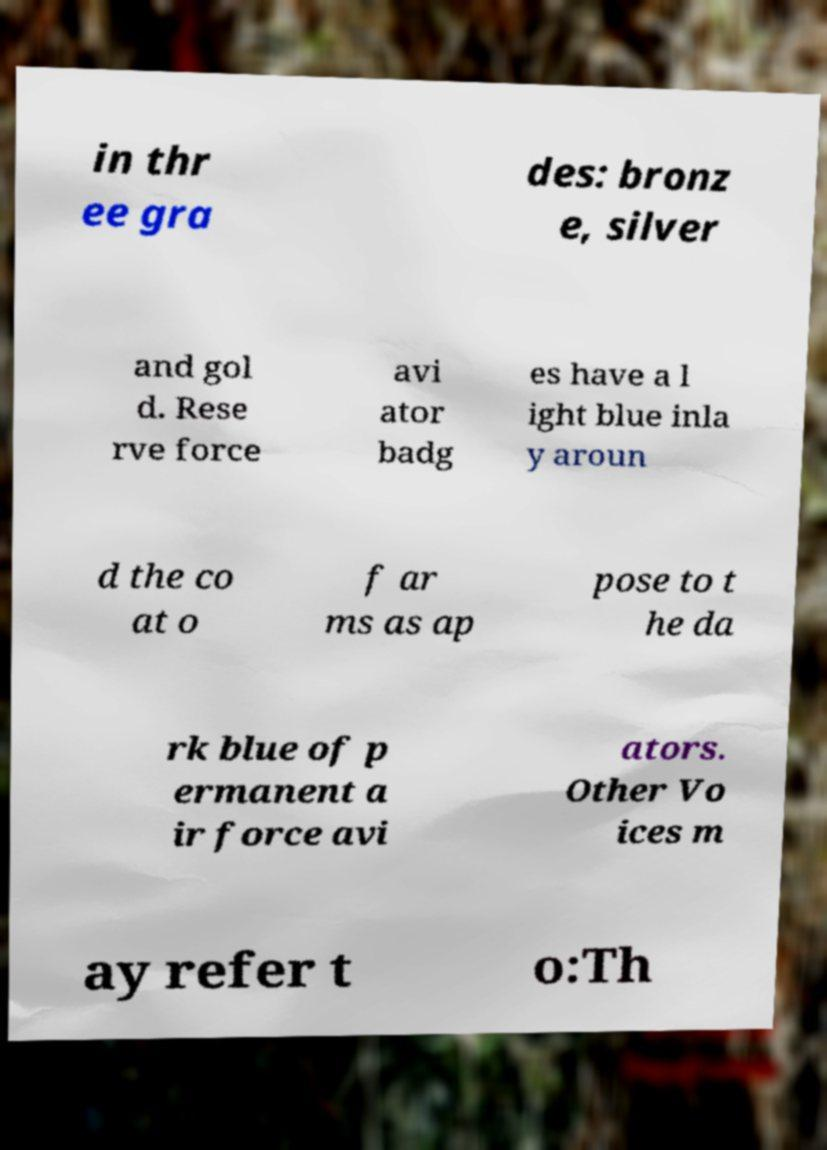Can you accurately transcribe the text from the provided image for me? in thr ee gra des: bronz e, silver and gol d. Rese rve force avi ator badg es have a l ight blue inla y aroun d the co at o f ar ms as ap pose to t he da rk blue of p ermanent a ir force avi ators. Other Vo ices m ay refer t o:Th 